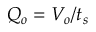Convert formula to latex. <formula><loc_0><loc_0><loc_500><loc_500>Q _ { o } = V _ { o } / t _ { s }</formula> 